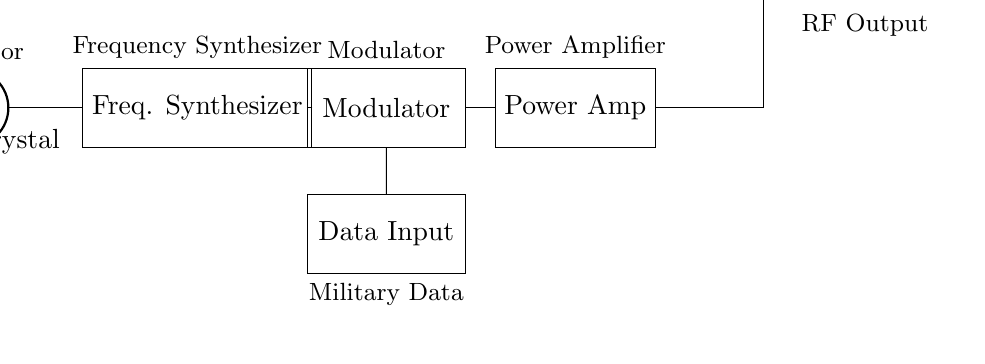What component is connected to the oscillator? The connection from the oscillator leads directly to the frequency synthesizer, indicating that the oscillator's output is directed into the frequency synthesizer as part of the signal processing chain.
Answer: Frequency synthesizer What is the last component before RF output? The power amplifier is situated directly before the antenna, which is responsible for transmitting the modulated RF signal. Thus, the power amplifier is last in the signal processing chain prior to output.
Answer: Power amplifier Which component modulates the data input? The modulator is connected to the data input, showing that the data to be transmitted is prepared for transmission by being combined with the carrier wave produced by the oscillator and processed through the frequency synthesizer.
Answer: Modulator What type of circuit is depicted in the diagram? The circuit is designed for wireless communication, specifically as a radio frequency transmitter, used for military applications to transmit various data reliably over a distance.
Answer: RF transmitter Which component is essential for signal transmission? The antenna is the component that facilitates the actual transmission of the radio frequency signals into the air, thus making it essential for effective communication in the circuit depicted.
Answer: Antenna How many processing stages does the signal go through? The signal passes through four main components before transmission: oscillator, frequency synthesizer, modulator, and power amplifier, indicating four critical processing stages.
Answer: Four What type of data is input to the circuit? The circuit is intended to accept military data as input, which is processed for communication via the RF transmitter components.
Answer: Military data 